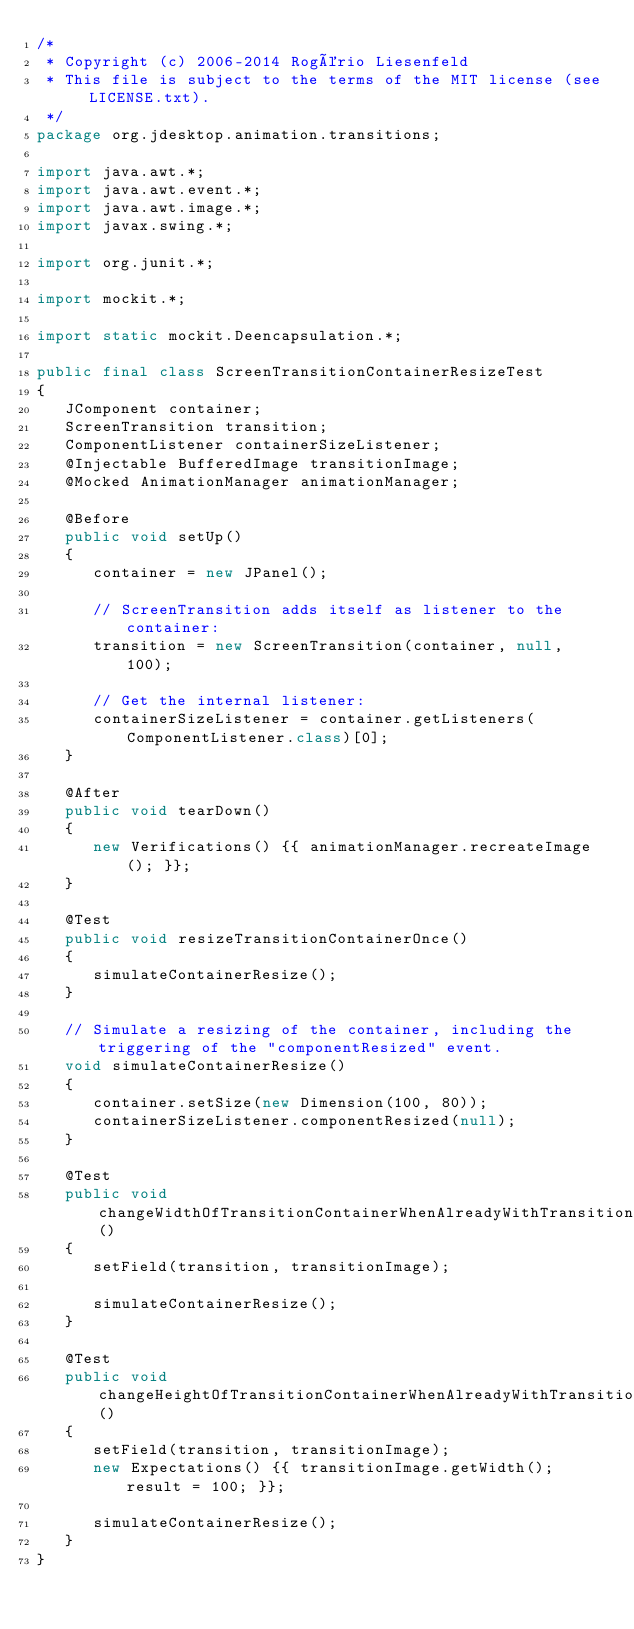Convert code to text. <code><loc_0><loc_0><loc_500><loc_500><_Java_>/*
 * Copyright (c) 2006-2014 Rogério Liesenfeld
 * This file is subject to the terms of the MIT license (see LICENSE.txt).
 */
package org.jdesktop.animation.transitions;

import java.awt.*;
import java.awt.event.*;
import java.awt.image.*;
import javax.swing.*;

import org.junit.*;

import mockit.*;

import static mockit.Deencapsulation.*;

public final class ScreenTransitionContainerResizeTest
{
   JComponent container;
   ScreenTransition transition;
   ComponentListener containerSizeListener;
   @Injectable BufferedImage transitionImage;
   @Mocked AnimationManager animationManager;

   @Before
   public void setUp()
   {
      container = new JPanel();

      // ScreenTransition adds itself as listener to the container:
      transition = new ScreenTransition(container, null, 100);

      // Get the internal listener:
      containerSizeListener = container.getListeners(ComponentListener.class)[0];
   }

   @After
   public void tearDown()
   {
      new Verifications() {{ animationManager.recreateImage(); }};
   }

   @Test
   public void resizeTransitionContainerOnce()
   {
      simulateContainerResize();
   }

   // Simulate a resizing of the container, including the triggering of the "componentResized" event.
   void simulateContainerResize()
   {
      container.setSize(new Dimension(100, 80));
      containerSizeListener.componentResized(null);
   }

   @Test
   public void changeWidthOfTransitionContainerWhenAlreadyWithTransitionImage()
   {
      setField(transition, transitionImage);

      simulateContainerResize();
   }

   @Test
   public void changeHeightOfTransitionContainerWhenAlreadyWithTransitionImage()
   {
      setField(transition, transitionImage);
      new Expectations() {{ transitionImage.getWidth(); result = 100; }};

      simulateContainerResize();
   }
}
</code> 